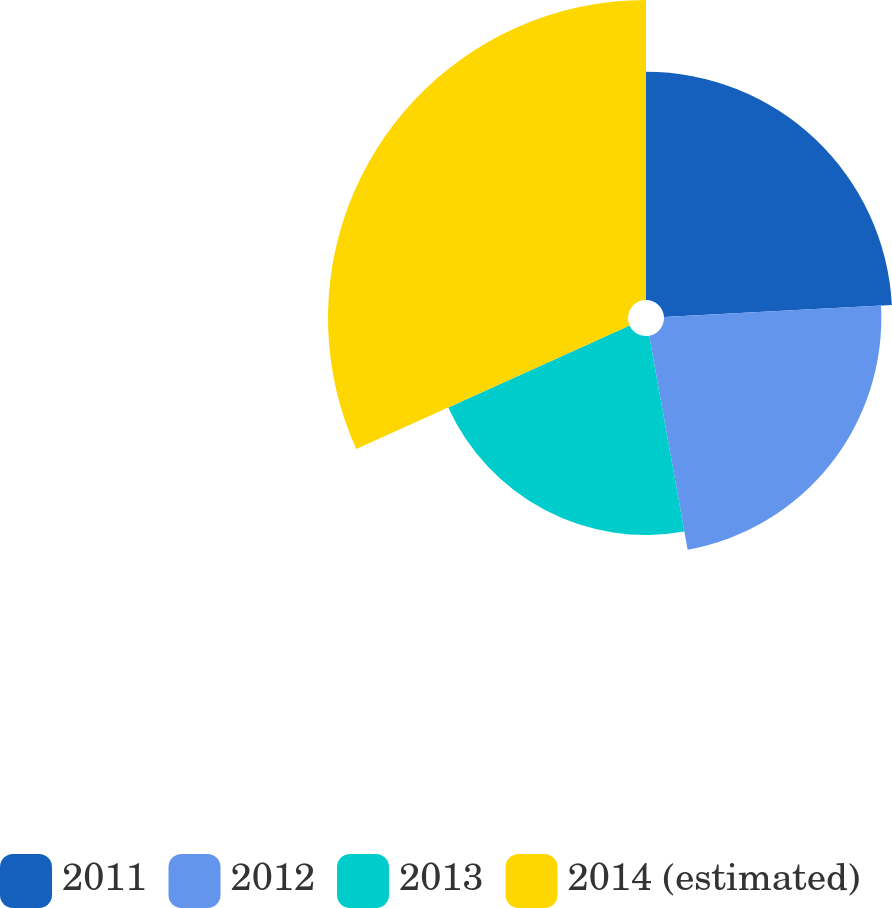Convert chart to OTSL. <chart><loc_0><loc_0><loc_500><loc_500><pie_chart><fcel>2011<fcel>2012<fcel>2013<fcel>2014 (estimated)<nl><fcel>24.16%<fcel>23.01%<fcel>21.07%<fcel>31.76%<nl></chart> 